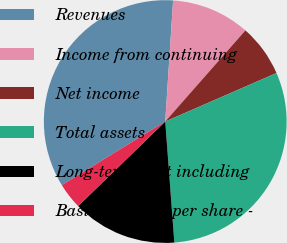<chart> <loc_0><loc_0><loc_500><loc_500><pie_chart><fcel>Revenues<fcel>Income from continuing<fcel>Net income<fcel>Total assets<fcel>Long-term debt including<fcel>Basic earnings per share -<nl><fcel>34.81%<fcel>10.45%<fcel>6.97%<fcel>30.35%<fcel>13.93%<fcel>3.49%<nl></chart> 